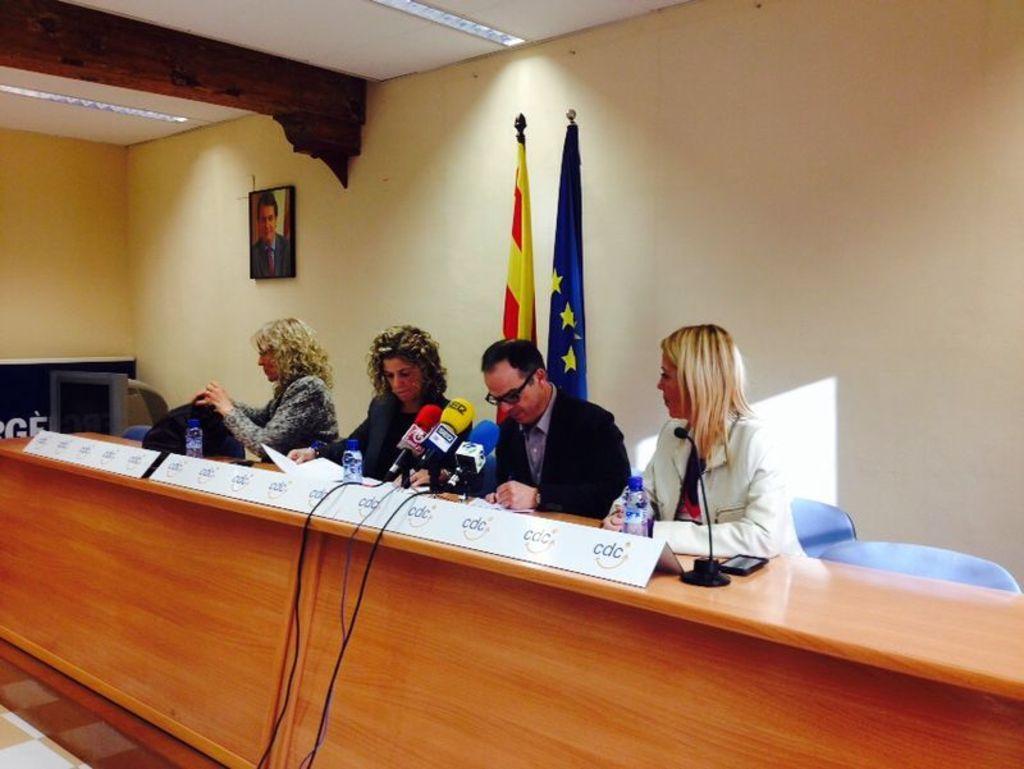Could you give a brief overview of what you see in this image? In this image three woman and man are sitting on the chair before a table having few miles, bottles and a mobile are on it. Behind the person there are two flags. A picture frame is attached to the wall. Woman at the left side of image is holding a bag in her hand, inside woman is holding paper. Behind them there is wall. Few lights are attached to the roof. 